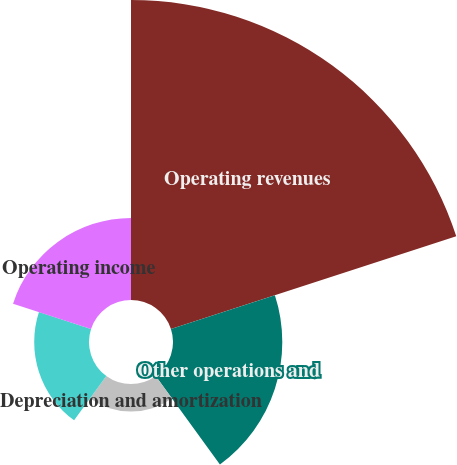<chart> <loc_0><loc_0><loc_500><loc_500><pie_chart><fcel>Operating revenues<fcel>Other operations and<fcel>Depreciation and amortization<fcel>Taxes other than income taxes<fcel>Operating income<nl><fcel>52.29%<fcel>19.05%<fcel>4.8%<fcel>9.55%<fcel>14.3%<nl></chart> 